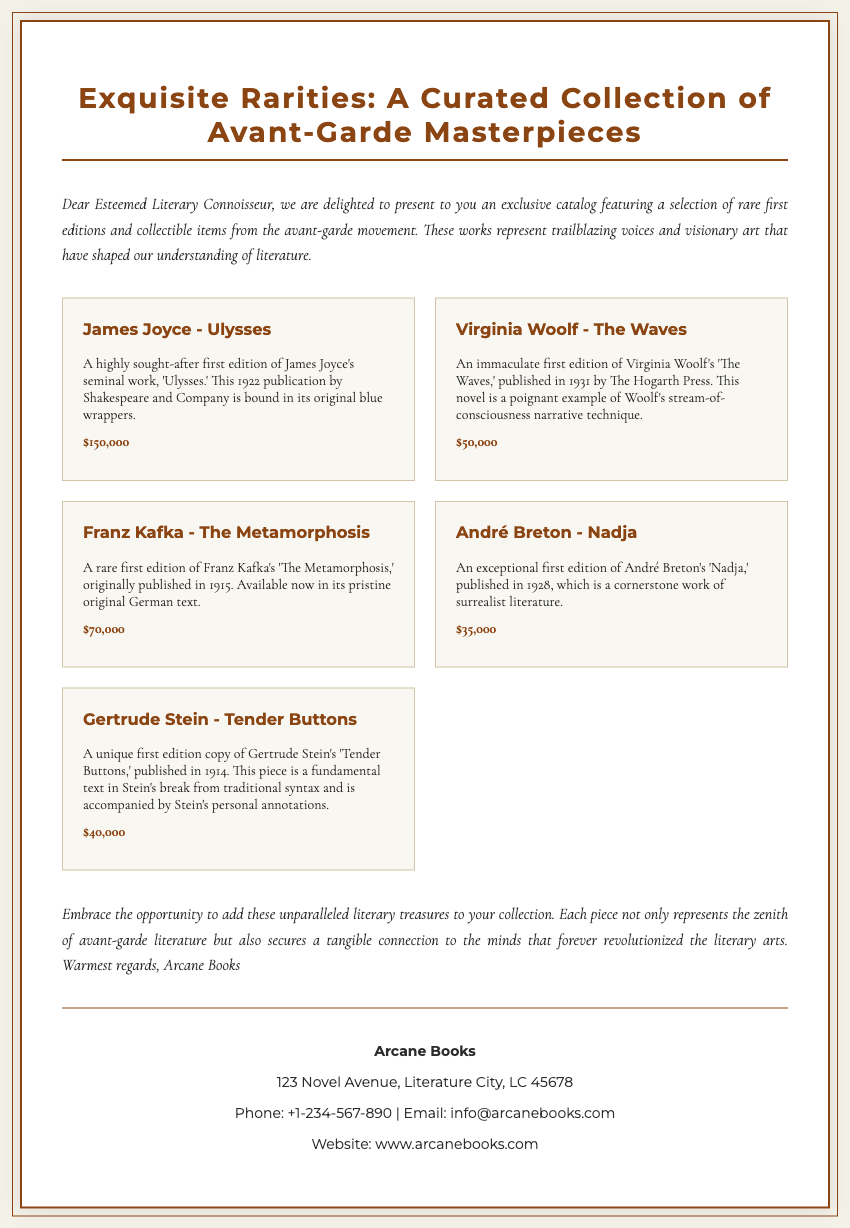what is the title of the catalog? The title is prominently displayed at the top of the document, stating "Exquisite Rarities: A Curated Collection of Avant-Garde Masterpieces."
Answer: Exquisite Rarities: A Curated Collection of Avant-Garde Masterpieces who wrote "Ulysses"? The catalog mentions James Joyce as the author of the featured book, 'Ulysses.'
Answer: James Joyce what year was "The Waves" published? The publication year of Virginia Woolf's 'The Waves' is provided as 1931 in the catalog.
Answer: 1931 how much is the asking price for "Tender Buttons"? The document specifies the asking price for 'Tender Buttons' as $40,000.
Answer: $40,000 which item has the highest price? By comparing all listed prices, 'Ulysses' is identified as the item with the highest asking price.
Answer: Ulysses what genre does "Nadja" belong to? The catalog describes 'Nadja' as a cornerstone work of surrealist literature.
Answer: surrealist literature how many first editions are listed in the catalog? The catalog features a total of five first editions from various authors.
Answer: five where is Arcane Books located? The catalog provides the address of Arcane Books as "123 Novel Avenue, Literature City, LC 45678."
Answer: 123 Novel Avenue, Literature City, LC 45678 what type of narrative technique does "The Waves" exemplify? The document denotes that 'The Waves' is a poignant example of stream-of-consciousness narrative technique.
Answer: stream-of-consciousness 